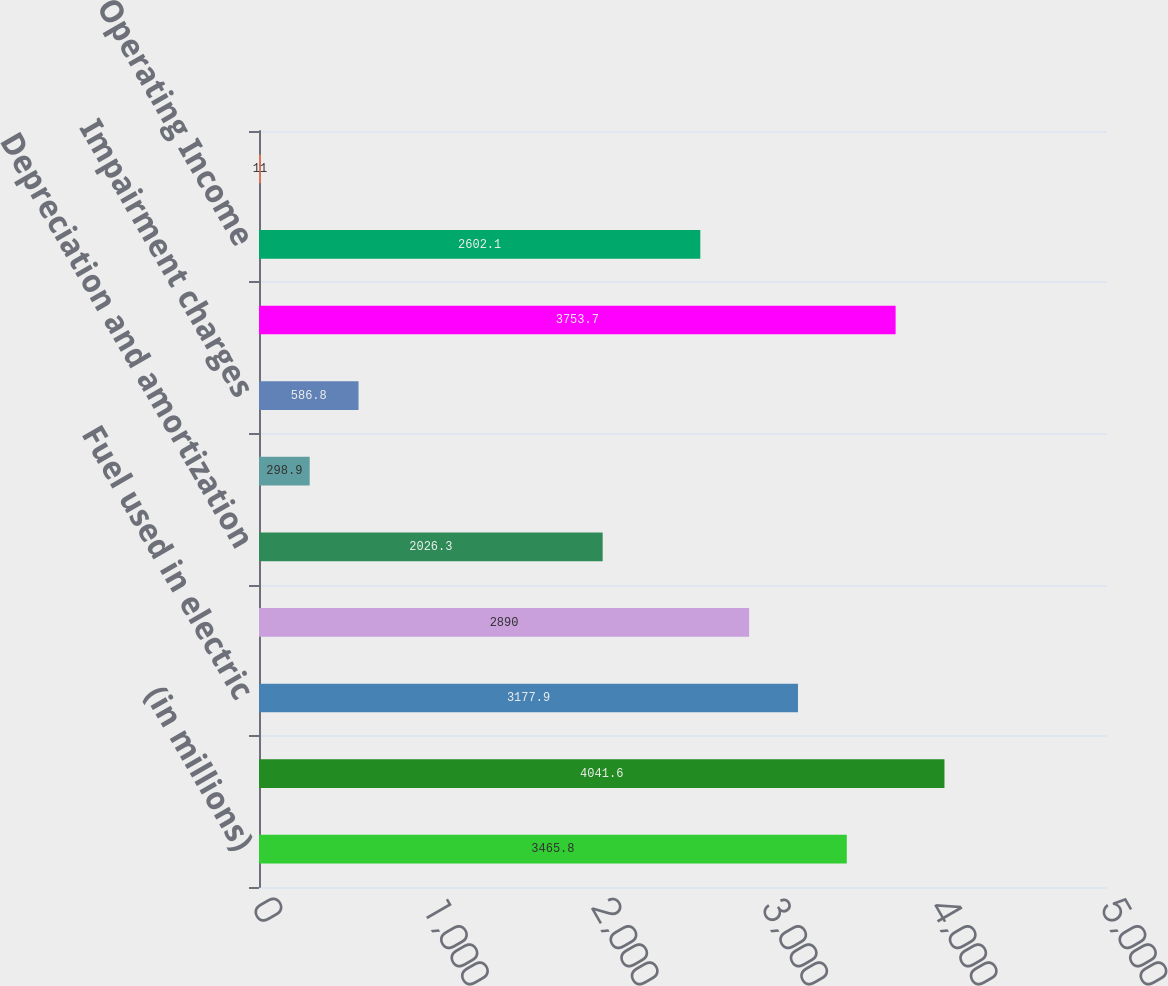Convert chart. <chart><loc_0><loc_0><loc_500><loc_500><bar_chart><fcel>(in millions)<fcel>Operating Revenues<fcel>Fuel used in electric<fcel>Operation maintenance and<fcel>Depreciation and amortization<fcel>Property and other taxes<fcel>Impairment charges<fcel>Total operating expenses<fcel>Operating Income<fcel>Other Income and Expenses net<nl><fcel>3465.8<fcel>4041.6<fcel>3177.9<fcel>2890<fcel>2026.3<fcel>298.9<fcel>586.8<fcel>3753.7<fcel>2602.1<fcel>11<nl></chart> 